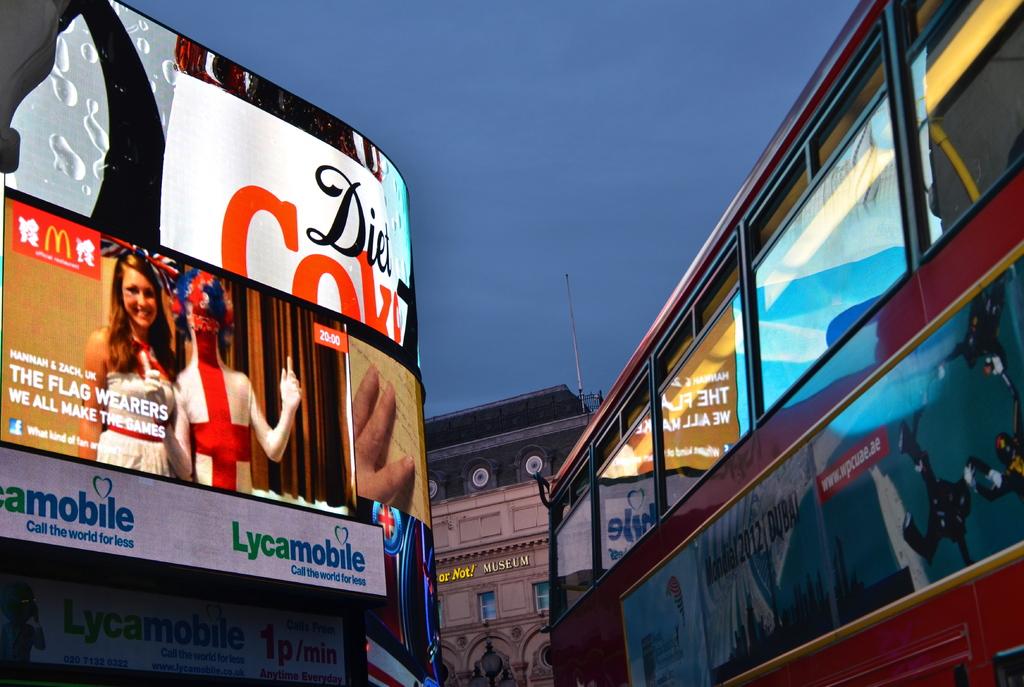What is the drink advertised on the left?
Offer a very short reply. Diet coke. What company has the sloan "call the world for less"?
Your answer should be very brief. Lycamobile. 